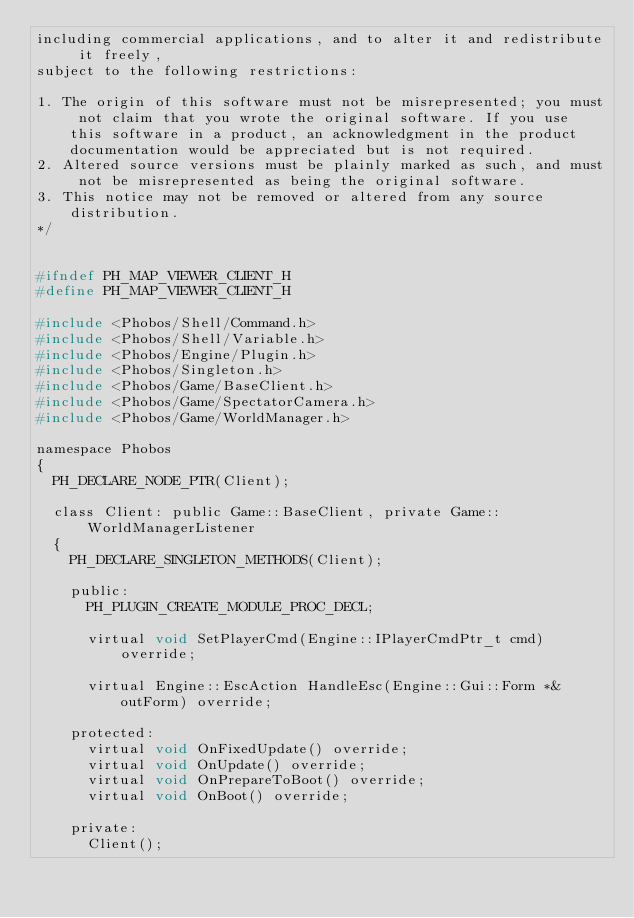Convert code to text. <code><loc_0><loc_0><loc_500><loc_500><_C_>including commercial applications, and to alter it and redistribute it freely, 
subject to the following restrictions:

1. The origin of this software must not be misrepresented; you must not claim that you wrote the original software. If you use this software in a product, an acknowledgment in the product documentation would be appreciated but is not required.
2. Altered source versions must be plainly marked as such, and must not be misrepresented as being the original software.
3. This notice may not be removed or altered from any source distribution.
*/


#ifndef PH_MAP_VIEWER_CLIENT_H
#define PH_MAP_VIEWER_CLIENT_H

#include <Phobos/Shell/Command.h>
#include <Phobos/Shell/Variable.h>
#include <Phobos/Engine/Plugin.h>
#include <Phobos/Singleton.h>
#include <Phobos/Game/BaseClient.h>
#include <Phobos/Game/SpectatorCamera.h>
#include <Phobos/Game/WorldManager.h>

namespace Phobos
{
	PH_DECLARE_NODE_PTR(Client);

	class Client: public Game::BaseClient, private Game::WorldManagerListener
	{
		PH_DECLARE_SINGLETON_METHODS(Client);

		public:
			PH_PLUGIN_CREATE_MODULE_PROC_DECL;

			virtual void SetPlayerCmd(Engine::IPlayerCmdPtr_t cmd) override;

			virtual Engine::EscAction HandleEsc(Engine::Gui::Form *&outForm) override;

		protected:
			virtual void OnFixedUpdate() override;
			virtual void OnUpdate() override;			
			virtual void OnPrepareToBoot() override;
			virtual void OnBoot() override;			

		private:
			Client();
</code> 